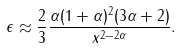Convert formula to latex. <formula><loc_0><loc_0><loc_500><loc_500>\epsilon \approx \frac { 2 } { 3 } \frac { \alpha ( 1 + \alpha ) ^ { 2 } ( 3 \alpha + 2 ) } { x ^ { 2 - 2 \alpha } } .</formula> 